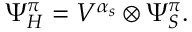Convert formula to latex. <formula><loc_0><loc_0><loc_500><loc_500>\Psi _ { H } ^ { \pi } = V ^ { \alpha _ { s } } \otimes \Psi _ { S } ^ { \pi } .</formula> 